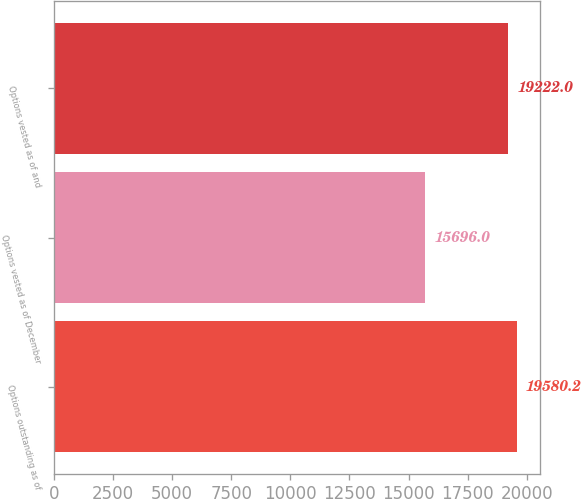Convert chart. <chart><loc_0><loc_0><loc_500><loc_500><bar_chart><fcel>Options outstanding as of<fcel>Options vested as of December<fcel>Options vested as of and<nl><fcel>19580.2<fcel>15696<fcel>19222<nl></chart> 